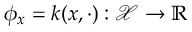Convert formula to latex. <formula><loc_0><loc_0><loc_500><loc_500>\phi _ { x } = k ( x , \cdot ) \colon \mathcal { X } \to \mathbb { R }</formula> 